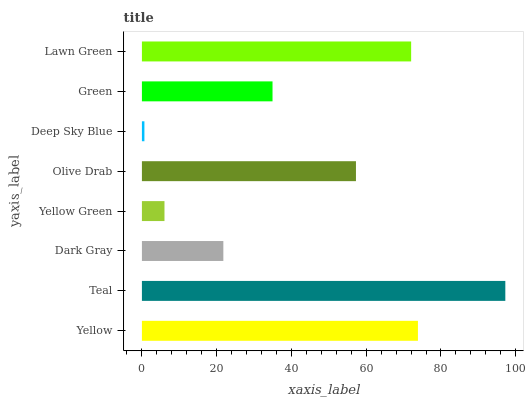Is Deep Sky Blue the minimum?
Answer yes or no. Yes. Is Teal the maximum?
Answer yes or no. Yes. Is Dark Gray the minimum?
Answer yes or no. No. Is Dark Gray the maximum?
Answer yes or no. No. Is Teal greater than Dark Gray?
Answer yes or no. Yes. Is Dark Gray less than Teal?
Answer yes or no. Yes. Is Dark Gray greater than Teal?
Answer yes or no. No. Is Teal less than Dark Gray?
Answer yes or no. No. Is Olive Drab the high median?
Answer yes or no. Yes. Is Green the low median?
Answer yes or no. Yes. Is Lawn Green the high median?
Answer yes or no. No. Is Dark Gray the low median?
Answer yes or no. No. 